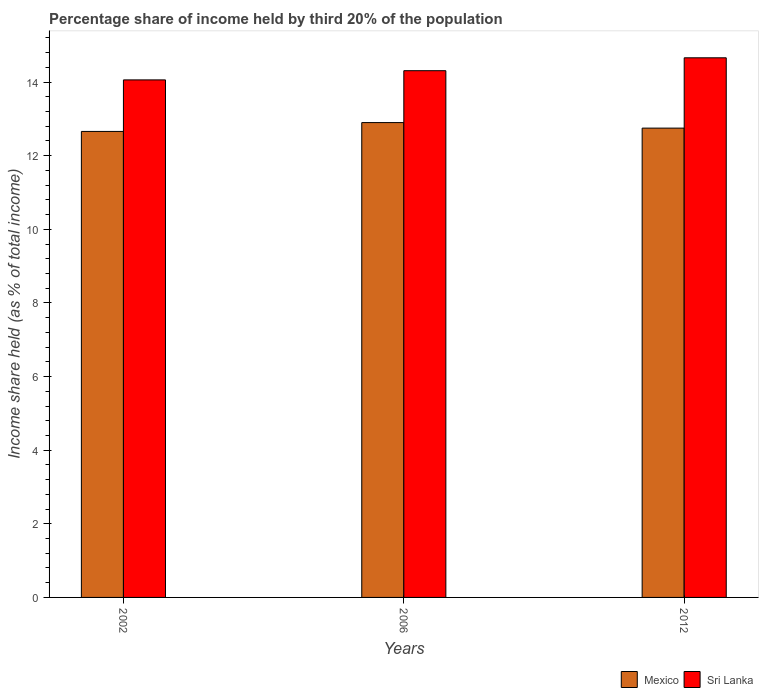How many groups of bars are there?
Make the answer very short. 3. Are the number of bars per tick equal to the number of legend labels?
Ensure brevity in your answer.  Yes. Are the number of bars on each tick of the X-axis equal?
Your answer should be compact. Yes. How many bars are there on the 1st tick from the right?
Give a very brief answer. 2. What is the share of income held by third 20% of the population in Sri Lanka in 2012?
Give a very brief answer. 14.66. Across all years, what is the maximum share of income held by third 20% of the population in Sri Lanka?
Provide a short and direct response. 14.66. Across all years, what is the minimum share of income held by third 20% of the population in Mexico?
Provide a succinct answer. 12.66. In which year was the share of income held by third 20% of the population in Mexico minimum?
Your answer should be compact. 2002. What is the total share of income held by third 20% of the population in Mexico in the graph?
Ensure brevity in your answer.  38.31. What is the difference between the share of income held by third 20% of the population in Mexico in 2002 and that in 2012?
Your answer should be compact. -0.09. What is the difference between the share of income held by third 20% of the population in Mexico in 2006 and the share of income held by third 20% of the population in Sri Lanka in 2002?
Your response must be concise. -1.16. What is the average share of income held by third 20% of the population in Sri Lanka per year?
Provide a short and direct response. 14.34. In the year 2012, what is the difference between the share of income held by third 20% of the population in Sri Lanka and share of income held by third 20% of the population in Mexico?
Give a very brief answer. 1.91. In how many years, is the share of income held by third 20% of the population in Mexico greater than 12.4 %?
Ensure brevity in your answer.  3. What is the ratio of the share of income held by third 20% of the population in Mexico in 2002 to that in 2006?
Your answer should be very brief. 0.98. Is the share of income held by third 20% of the population in Sri Lanka in 2002 less than that in 2012?
Your answer should be very brief. Yes. Is the difference between the share of income held by third 20% of the population in Sri Lanka in 2002 and 2012 greater than the difference between the share of income held by third 20% of the population in Mexico in 2002 and 2012?
Provide a short and direct response. No. What is the difference between the highest and the second highest share of income held by third 20% of the population in Sri Lanka?
Your answer should be very brief. 0.35. What is the difference between the highest and the lowest share of income held by third 20% of the population in Mexico?
Give a very brief answer. 0.24. In how many years, is the share of income held by third 20% of the population in Sri Lanka greater than the average share of income held by third 20% of the population in Sri Lanka taken over all years?
Offer a terse response. 1. What does the 2nd bar from the left in 2012 represents?
Offer a terse response. Sri Lanka. What does the 1st bar from the right in 2012 represents?
Your answer should be very brief. Sri Lanka. How many years are there in the graph?
Make the answer very short. 3. Does the graph contain grids?
Make the answer very short. No. Where does the legend appear in the graph?
Offer a terse response. Bottom right. What is the title of the graph?
Make the answer very short. Percentage share of income held by third 20% of the population. Does "Guyana" appear as one of the legend labels in the graph?
Ensure brevity in your answer.  No. What is the label or title of the Y-axis?
Your answer should be very brief. Income share held (as % of total income). What is the Income share held (as % of total income) of Mexico in 2002?
Make the answer very short. 12.66. What is the Income share held (as % of total income) in Sri Lanka in 2002?
Make the answer very short. 14.06. What is the Income share held (as % of total income) of Sri Lanka in 2006?
Keep it short and to the point. 14.31. What is the Income share held (as % of total income) of Mexico in 2012?
Make the answer very short. 12.75. What is the Income share held (as % of total income) of Sri Lanka in 2012?
Offer a very short reply. 14.66. Across all years, what is the maximum Income share held (as % of total income) in Sri Lanka?
Offer a terse response. 14.66. Across all years, what is the minimum Income share held (as % of total income) in Mexico?
Provide a succinct answer. 12.66. Across all years, what is the minimum Income share held (as % of total income) in Sri Lanka?
Provide a short and direct response. 14.06. What is the total Income share held (as % of total income) in Mexico in the graph?
Provide a short and direct response. 38.31. What is the total Income share held (as % of total income) of Sri Lanka in the graph?
Your answer should be very brief. 43.03. What is the difference between the Income share held (as % of total income) in Mexico in 2002 and that in 2006?
Your answer should be compact. -0.24. What is the difference between the Income share held (as % of total income) of Sri Lanka in 2002 and that in 2006?
Provide a succinct answer. -0.25. What is the difference between the Income share held (as % of total income) in Mexico in 2002 and that in 2012?
Your response must be concise. -0.09. What is the difference between the Income share held (as % of total income) of Sri Lanka in 2006 and that in 2012?
Give a very brief answer. -0.35. What is the difference between the Income share held (as % of total income) of Mexico in 2002 and the Income share held (as % of total income) of Sri Lanka in 2006?
Ensure brevity in your answer.  -1.65. What is the difference between the Income share held (as % of total income) of Mexico in 2002 and the Income share held (as % of total income) of Sri Lanka in 2012?
Give a very brief answer. -2. What is the difference between the Income share held (as % of total income) in Mexico in 2006 and the Income share held (as % of total income) in Sri Lanka in 2012?
Keep it short and to the point. -1.76. What is the average Income share held (as % of total income) of Mexico per year?
Ensure brevity in your answer.  12.77. What is the average Income share held (as % of total income) in Sri Lanka per year?
Your answer should be very brief. 14.34. In the year 2006, what is the difference between the Income share held (as % of total income) in Mexico and Income share held (as % of total income) in Sri Lanka?
Give a very brief answer. -1.41. In the year 2012, what is the difference between the Income share held (as % of total income) of Mexico and Income share held (as % of total income) of Sri Lanka?
Give a very brief answer. -1.91. What is the ratio of the Income share held (as % of total income) of Mexico in 2002 to that in 2006?
Give a very brief answer. 0.98. What is the ratio of the Income share held (as % of total income) in Sri Lanka in 2002 to that in 2006?
Provide a succinct answer. 0.98. What is the ratio of the Income share held (as % of total income) of Mexico in 2002 to that in 2012?
Give a very brief answer. 0.99. What is the ratio of the Income share held (as % of total income) of Sri Lanka in 2002 to that in 2012?
Make the answer very short. 0.96. What is the ratio of the Income share held (as % of total income) of Mexico in 2006 to that in 2012?
Provide a short and direct response. 1.01. What is the ratio of the Income share held (as % of total income) of Sri Lanka in 2006 to that in 2012?
Make the answer very short. 0.98. What is the difference between the highest and the second highest Income share held (as % of total income) of Mexico?
Keep it short and to the point. 0.15. What is the difference between the highest and the lowest Income share held (as % of total income) of Mexico?
Your answer should be compact. 0.24. What is the difference between the highest and the lowest Income share held (as % of total income) of Sri Lanka?
Keep it short and to the point. 0.6. 